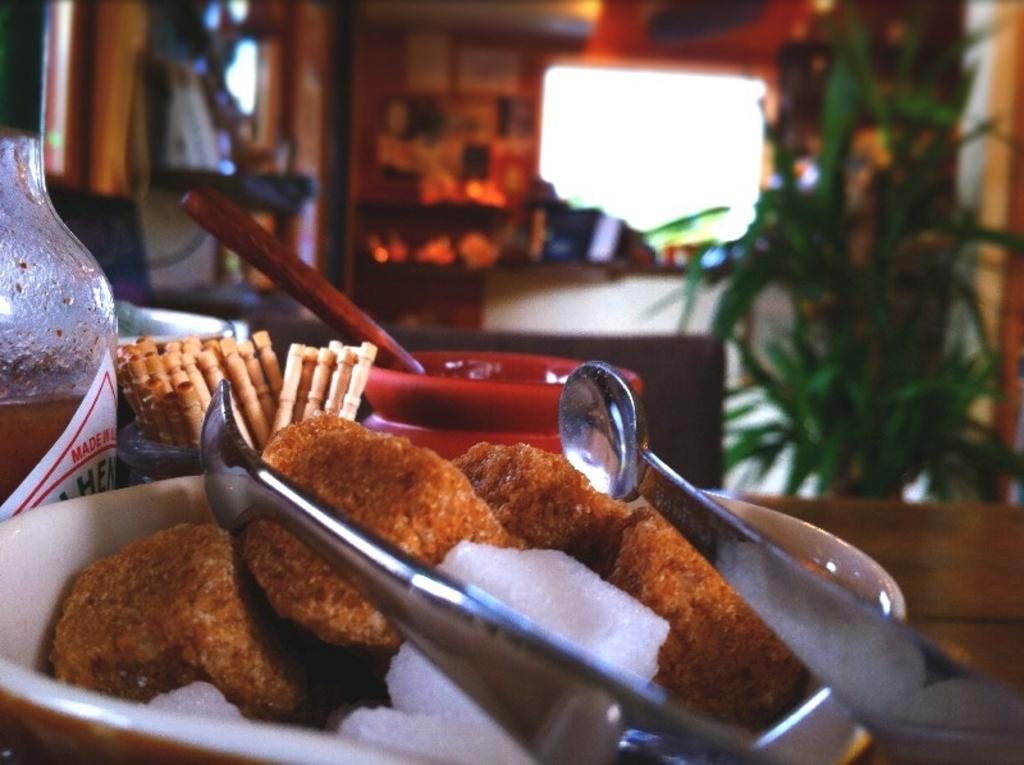What is in the bowl that is visible in the image? There is a food item in a bowl in the image. What can be seen behind the bowl? There are objects behind the bowl. What is on the right side of the image? There is a wall and a plant on the right side of the image. How would you describe the background of the image? The background of the image is blurred. What type of debt is being discussed in the image? There is no mention of debt in the image; it features a food item in a bowl, objects behind the bowl, a wall and plant on the right side, and a blurred background. 